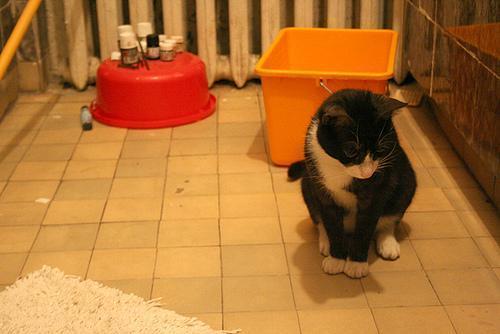How many bikes are shown?
Give a very brief answer. 0. 